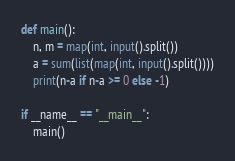<code> <loc_0><loc_0><loc_500><loc_500><_Python_>def main():
    n, m = map(int, input().split())
    a = sum(list(map(int, input().split())))
    print(n-a if n-a >= 0 else -1)

if __name__ == "__main__":
    main()</code> 